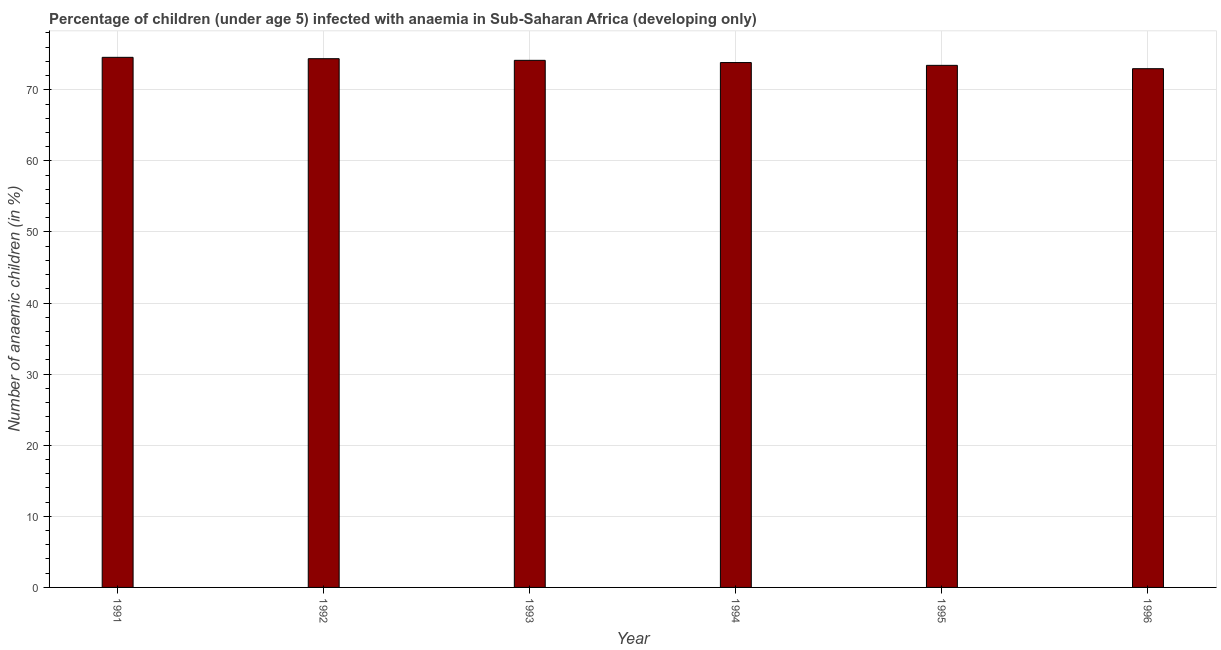Does the graph contain any zero values?
Your response must be concise. No. Does the graph contain grids?
Provide a succinct answer. Yes. What is the title of the graph?
Provide a short and direct response. Percentage of children (under age 5) infected with anaemia in Sub-Saharan Africa (developing only). What is the label or title of the X-axis?
Your response must be concise. Year. What is the label or title of the Y-axis?
Provide a short and direct response. Number of anaemic children (in %). What is the number of anaemic children in 1996?
Offer a terse response. 72.97. Across all years, what is the maximum number of anaemic children?
Give a very brief answer. 74.57. Across all years, what is the minimum number of anaemic children?
Your answer should be compact. 72.97. What is the sum of the number of anaemic children?
Keep it short and to the point. 443.33. What is the difference between the number of anaemic children in 1991 and 1994?
Keep it short and to the point. 0.73. What is the average number of anaemic children per year?
Provide a short and direct response. 73.89. What is the median number of anaemic children?
Offer a terse response. 73.99. In how many years, is the number of anaemic children greater than 42 %?
Offer a terse response. 6. What is the ratio of the number of anaemic children in 1993 to that in 1994?
Offer a terse response. 1. Is the number of anaemic children in 1994 less than that in 1995?
Your answer should be very brief. No. What is the difference between the highest and the second highest number of anaemic children?
Give a very brief answer. 0.19. Is the sum of the number of anaemic children in 1995 and 1996 greater than the maximum number of anaemic children across all years?
Your answer should be very brief. Yes. What is the difference between the highest and the lowest number of anaemic children?
Your response must be concise. 1.6. How many bars are there?
Offer a very short reply. 6. How many years are there in the graph?
Give a very brief answer. 6. What is the difference between two consecutive major ticks on the Y-axis?
Your answer should be compact. 10. Are the values on the major ticks of Y-axis written in scientific E-notation?
Ensure brevity in your answer.  No. What is the Number of anaemic children (in %) of 1991?
Keep it short and to the point. 74.57. What is the Number of anaemic children (in %) of 1992?
Make the answer very short. 74.38. What is the Number of anaemic children (in %) of 1993?
Keep it short and to the point. 74.15. What is the Number of anaemic children (in %) of 1994?
Give a very brief answer. 73.83. What is the Number of anaemic children (in %) of 1995?
Give a very brief answer. 73.44. What is the Number of anaemic children (in %) of 1996?
Your response must be concise. 72.97. What is the difference between the Number of anaemic children (in %) in 1991 and 1992?
Give a very brief answer. 0.19. What is the difference between the Number of anaemic children (in %) in 1991 and 1993?
Your answer should be very brief. 0.42. What is the difference between the Number of anaemic children (in %) in 1991 and 1994?
Ensure brevity in your answer.  0.74. What is the difference between the Number of anaemic children (in %) in 1991 and 1995?
Your response must be concise. 1.13. What is the difference between the Number of anaemic children (in %) in 1991 and 1996?
Provide a short and direct response. 1.6. What is the difference between the Number of anaemic children (in %) in 1992 and 1993?
Your answer should be very brief. 0.23. What is the difference between the Number of anaemic children (in %) in 1992 and 1994?
Your answer should be very brief. 0.54. What is the difference between the Number of anaemic children (in %) in 1992 and 1995?
Offer a very short reply. 0.94. What is the difference between the Number of anaemic children (in %) in 1992 and 1996?
Provide a short and direct response. 1.41. What is the difference between the Number of anaemic children (in %) in 1993 and 1994?
Your answer should be very brief. 0.31. What is the difference between the Number of anaemic children (in %) in 1993 and 1995?
Offer a terse response. 0.71. What is the difference between the Number of anaemic children (in %) in 1993 and 1996?
Provide a short and direct response. 1.18. What is the difference between the Number of anaemic children (in %) in 1994 and 1995?
Make the answer very short. 0.39. What is the difference between the Number of anaemic children (in %) in 1994 and 1996?
Your answer should be very brief. 0.86. What is the difference between the Number of anaemic children (in %) in 1995 and 1996?
Your response must be concise. 0.47. What is the ratio of the Number of anaemic children (in %) in 1991 to that in 1992?
Your response must be concise. 1. What is the ratio of the Number of anaemic children (in %) in 1991 to that in 1993?
Your answer should be very brief. 1.01. What is the ratio of the Number of anaemic children (in %) in 1991 to that in 1996?
Give a very brief answer. 1.02. What is the ratio of the Number of anaemic children (in %) in 1992 to that in 1994?
Your response must be concise. 1.01. What is the ratio of the Number of anaemic children (in %) in 1992 to that in 1996?
Keep it short and to the point. 1.02. What is the ratio of the Number of anaemic children (in %) in 1993 to that in 1996?
Provide a succinct answer. 1.02. What is the ratio of the Number of anaemic children (in %) in 1994 to that in 1995?
Offer a very short reply. 1. 